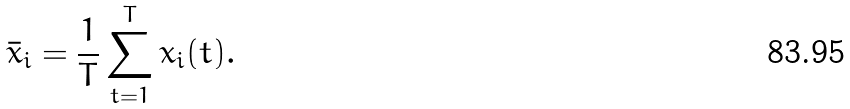Convert formula to latex. <formula><loc_0><loc_0><loc_500><loc_500>\bar { x } _ { i } = \frac { 1 } { T } \sum _ { t = 1 } ^ { T } x _ { i } ( t ) .</formula> 